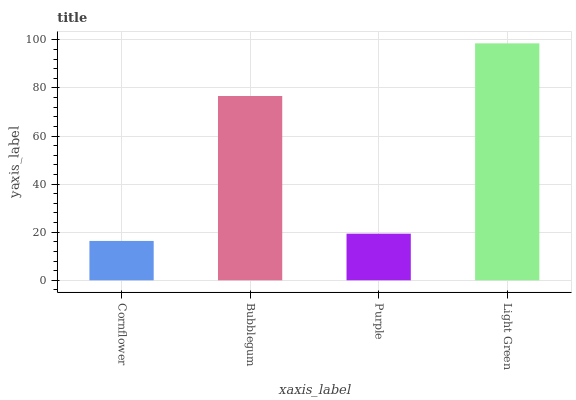Is Cornflower the minimum?
Answer yes or no. Yes. Is Light Green the maximum?
Answer yes or no. Yes. Is Bubblegum the minimum?
Answer yes or no. No. Is Bubblegum the maximum?
Answer yes or no. No. Is Bubblegum greater than Cornflower?
Answer yes or no. Yes. Is Cornflower less than Bubblegum?
Answer yes or no. Yes. Is Cornflower greater than Bubblegum?
Answer yes or no. No. Is Bubblegum less than Cornflower?
Answer yes or no. No. Is Bubblegum the high median?
Answer yes or no. Yes. Is Purple the low median?
Answer yes or no. Yes. Is Light Green the high median?
Answer yes or no. No. Is Bubblegum the low median?
Answer yes or no. No. 